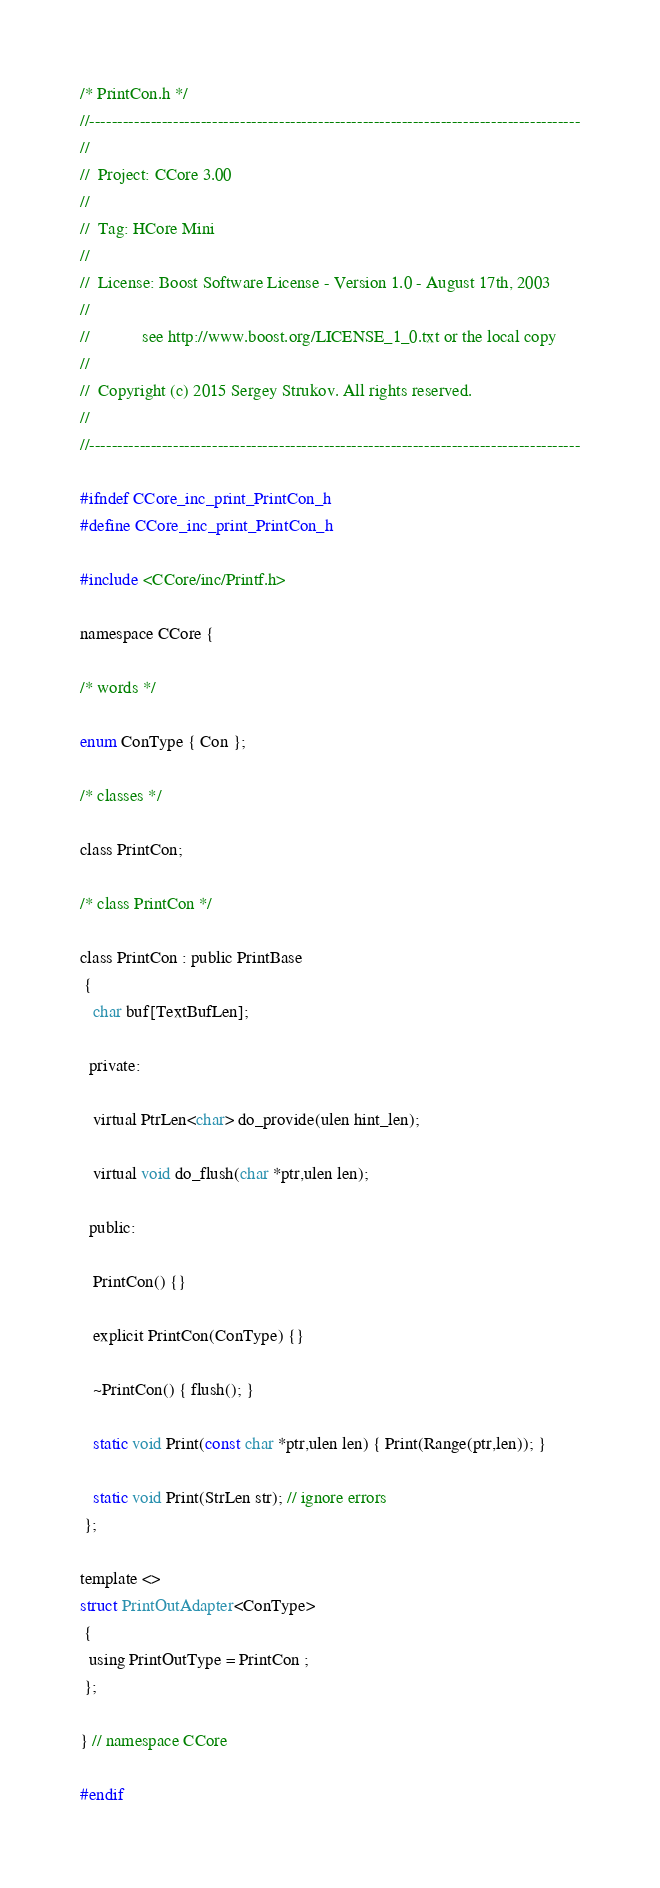<code> <loc_0><loc_0><loc_500><loc_500><_C_>/* PrintCon.h */
//----------------------------------------------------------------------------------------
//
//  Project: CCore 3.00
//
//  Tag: HCore Mini
//
//  License: Boost Software License - Version 1.0 - August 17th, 2003
//
//            see http://www.boost.org/LICENSE_1_0.txt or the local copy
//
//  Copyright (c) 2015 Sergey Strukov. All rights reserved.
//
//----------------------------------------------------------------------------------------

#ifndef CCore_inc_print_PrintCon_h
#define CCore_inc_print_PrintCon_h

#include <CCore/inc/Printf.h>

namespace CCore {

/* words */

enum ConType { Con };

/* classes */

class PrintCon;

/* class PrintCon */

class PrintCon : public PrintBase
 {
   char buf[TextBufLen];

  private:

   virtual PtrLen<char> do_provide(ulen hint_len);

   virtual void do_flush(char *ptr,ulen len);

  public:

   PrintCon() {}

   explicit PrintCon(ConType) {}

   ~PrintCon() { flush(); }

   static void Print(const char *ptr,ulen len) { Print(Range(ptr,len)); }

   static void Print(StrLen str); // ignore errors
 };

template <>
struct PrintOutAdapter<ConType>
 {
  using PrintOutType = PrintCon ;
 };

} // namespace CCore

#endif


</code> 